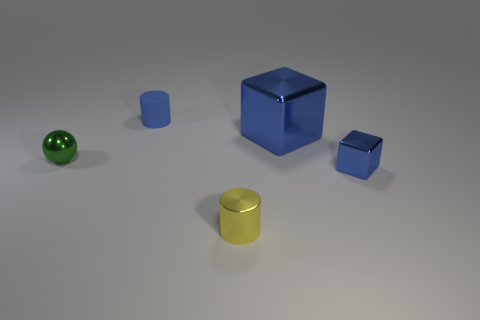Add 4 blue shiny things. How many objects exist? 9 Subtract all cylinders. How many objects are left? 3 Add 3 small green rubber cylinders. How many small green rubber cylinders exist? 3 Subtract 0 brown spheres. How many objects are left? 5 Subtract all red spheres. Subtract all matte cylinders. How many objects are left? 4 Add 1 tiny green shiny balls. How many tiny green shiny balls are left? 2 